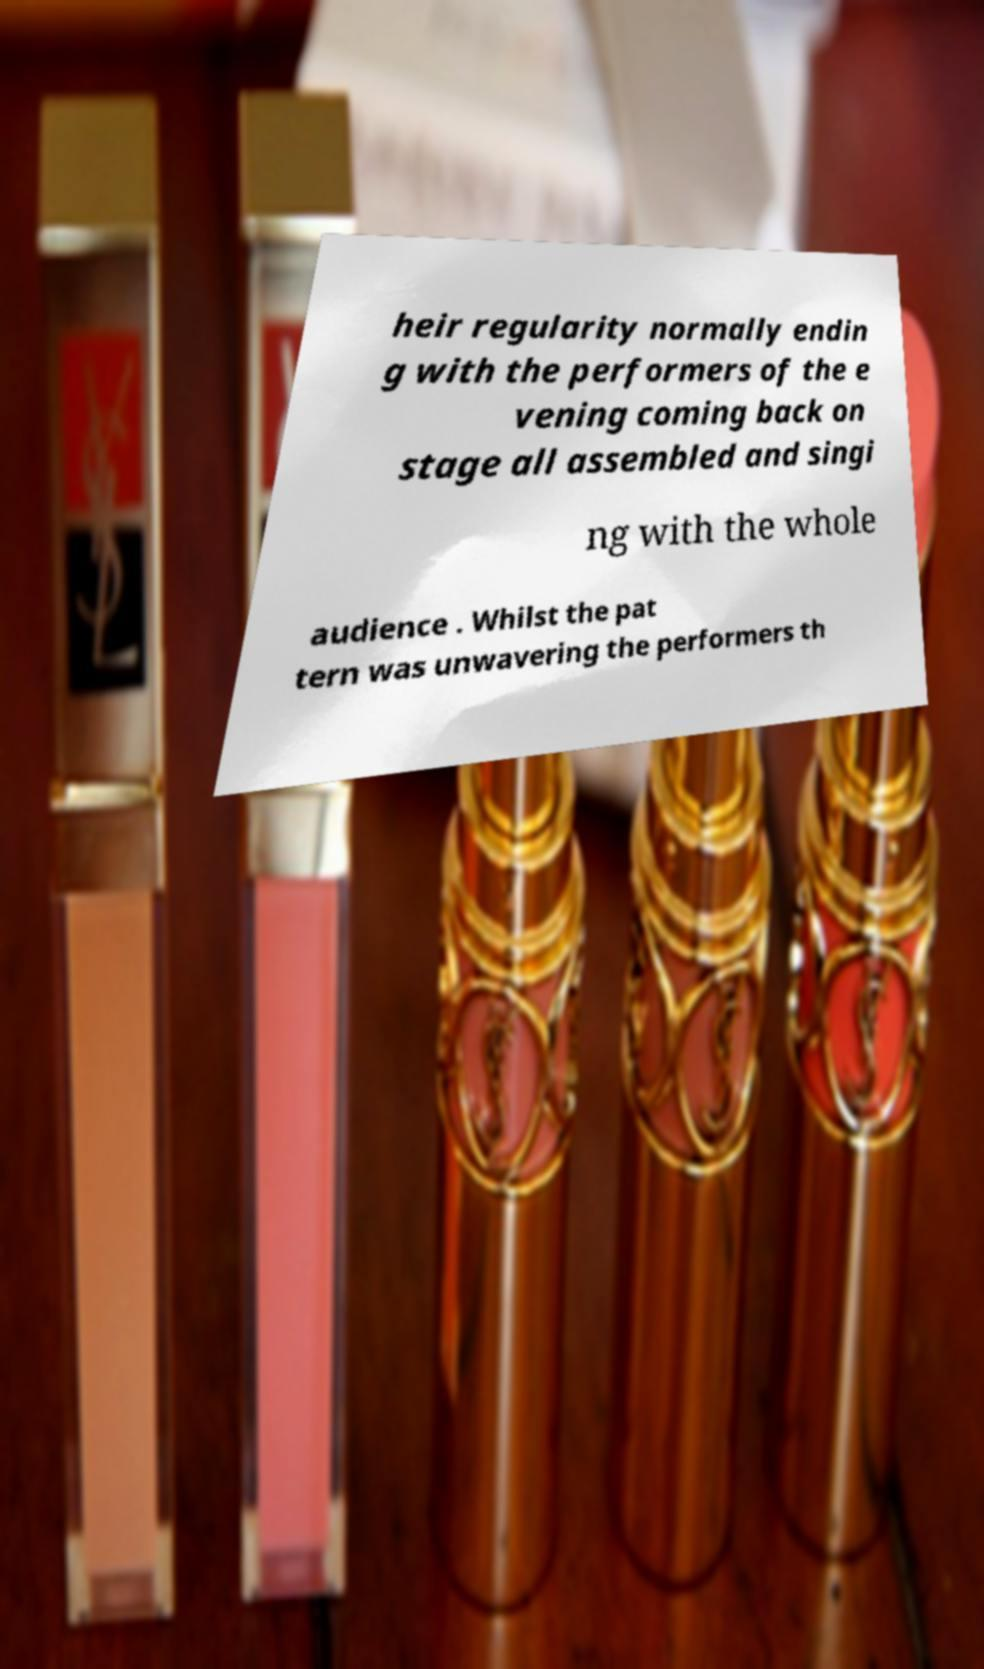Please read and relay the text visible in this image. What does it say? heir regularity normally endin g with the performers of the e vening coming back on stage all assembled and singi ng with the whole audience . Whilst the pat tern was unwavering the performers th 